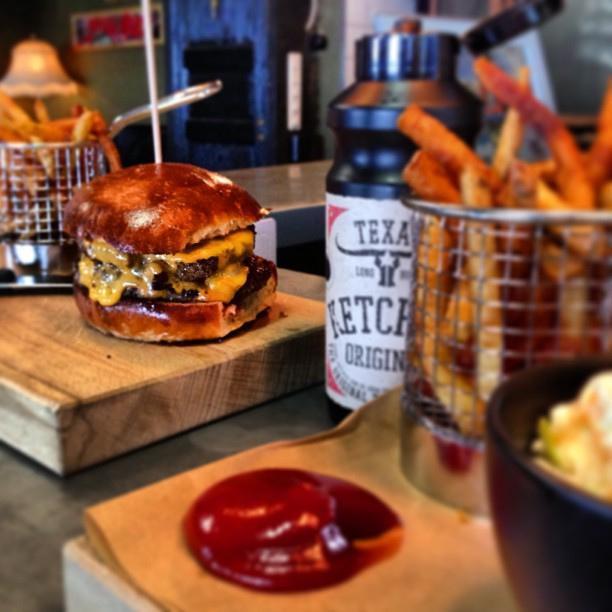Does the caption "The sandwich is at the left side of the bottle." correctly depict the image?
Answer yes or no. Yes. 